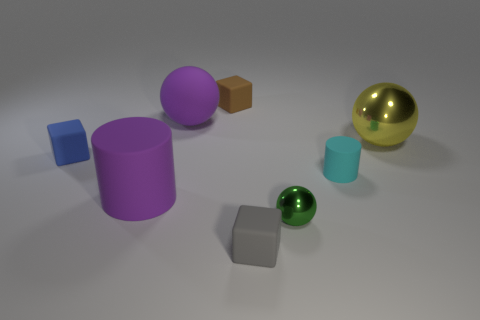There is a big object that is both left of the gray rubber thing and behind the big purple cylinder; what is its shape? sphere 